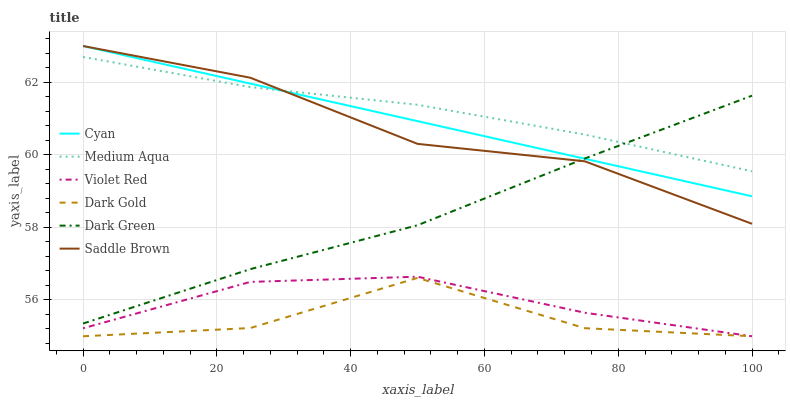Does Dark Gold have the minimum area under the curve?
Answer yes or no. Yes. Does Medium Aqua have the maximum area under the curve?
Answer yes or no. Yes. Does Medium Aqua have the minimum area under the curve?
Answer yes or no. No. Does Dark Gold have the maximum area under the curve?
Answer yes or no. No. Is Cyan the smoothest?
Answer yes or no. Yes. Is Dark Gold the roughest?
Answer yes or no. Yes. Is Medium Aqua the smoothest?
Answer yes or no. No. Is Medium Aqua the roughest?
Answer yes or no. No. Does Medium Aqua have the lowest value?
Answer yes or no. No. Does Medium Aqua have the highest value?
Answer yes or no. No. Is Dark Gold less than Dark Green?
Answer yes or no. Yes. Is Cyan greater than Violet Red?
Answer yes or no. Yes. Does Dark Gold intersect Dark Green?
Answer yes or no. No. 